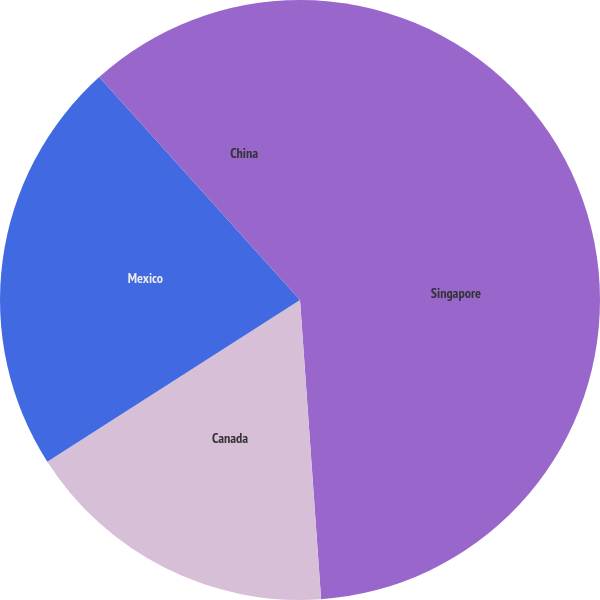<chart> <loc_0><loc_0><loc_500><loc_500><pie_chart><fcel>Singapore<fcel>Canada<fcel>Mexico<fcel>China<nl><fcel>48.88%<fcel>17.06%<fcel>22.39%<fcel>11.67%<nl></chart> 